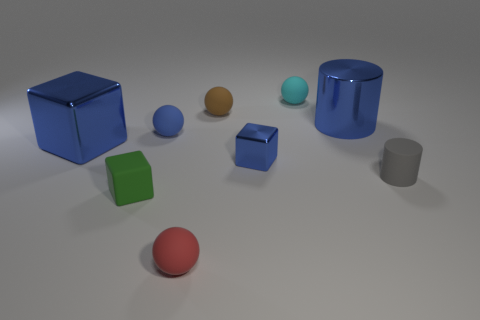Is there a matte sphere of the same color as the big cylinder?
Provide a succinct answer. Yes. Do the large metal block and the small cube that is on the right side of the red matte ball have the same color?
Offer a very short reply. Yes. What shape is the small object that is the same color as the small metal cube?
Offer a very short reply. Sphere. There is a rubber sphere in front of the green matte object; is its size the same as the blue shiny block behind the tiny shiny object?
Provide a short and direct response. No. What number of cylinders are either small brown things or green things?
Ensure brevity in your answer.  0. Are the cube that is in front of the tiny gray matte cylinder and the small blue block made of the same material?
Give a very brief answer. No. How many other things are the same size as the blue matte ball?
Provide a succinct answer. 6. How many small things are either gray cylinders or red rubber spheres?
Give a very brief answer. 2. Is the big shiny cylinder the same color as the tiny metallic object?
Your answer should be compact. Yes. Are there more small red objects on the right side of the small brown sphere than tiny blue metallic cubes that are behind the big metallic block?
Ensure brevity in your answer.  No. 